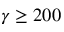Convert formula to latex. <formula><loc_0><loc_0><loc_500><loc_500>\gamma \geq 2 0 0</formula> 